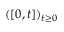<formula> <loc_0><loc_0><loc_500><loc_500>( [ 0 , t ] ) _ { t \geq 0 }</formula> 